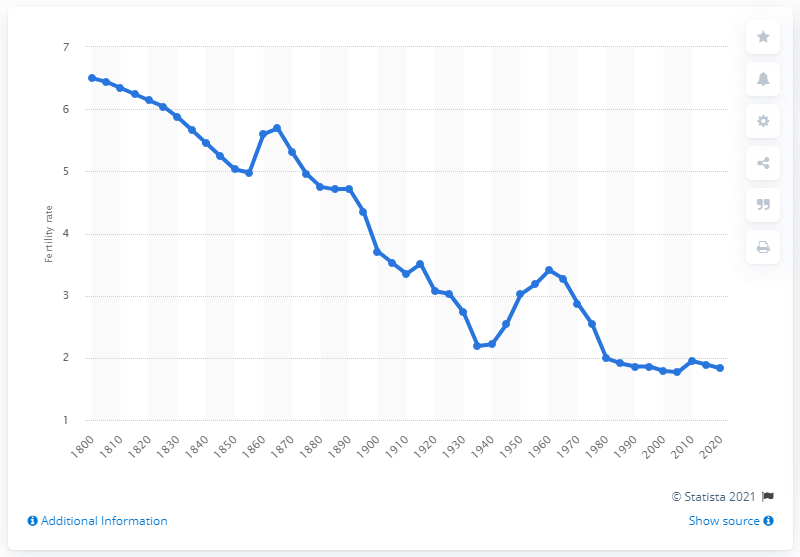Indicate a few pertinent items in this graphic. In 1800, the average number of children that Australian women of childbearing age would have was approximately 6.5. 